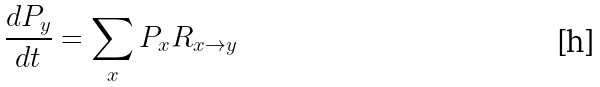Convert formula to latex. <formula><loc_0><loc_0><loc_500><loc_500>\frac { d P _ { y } } { d t } = \sum _ { x } P _ { x } R _ { x \rightarrow y }</formula> 